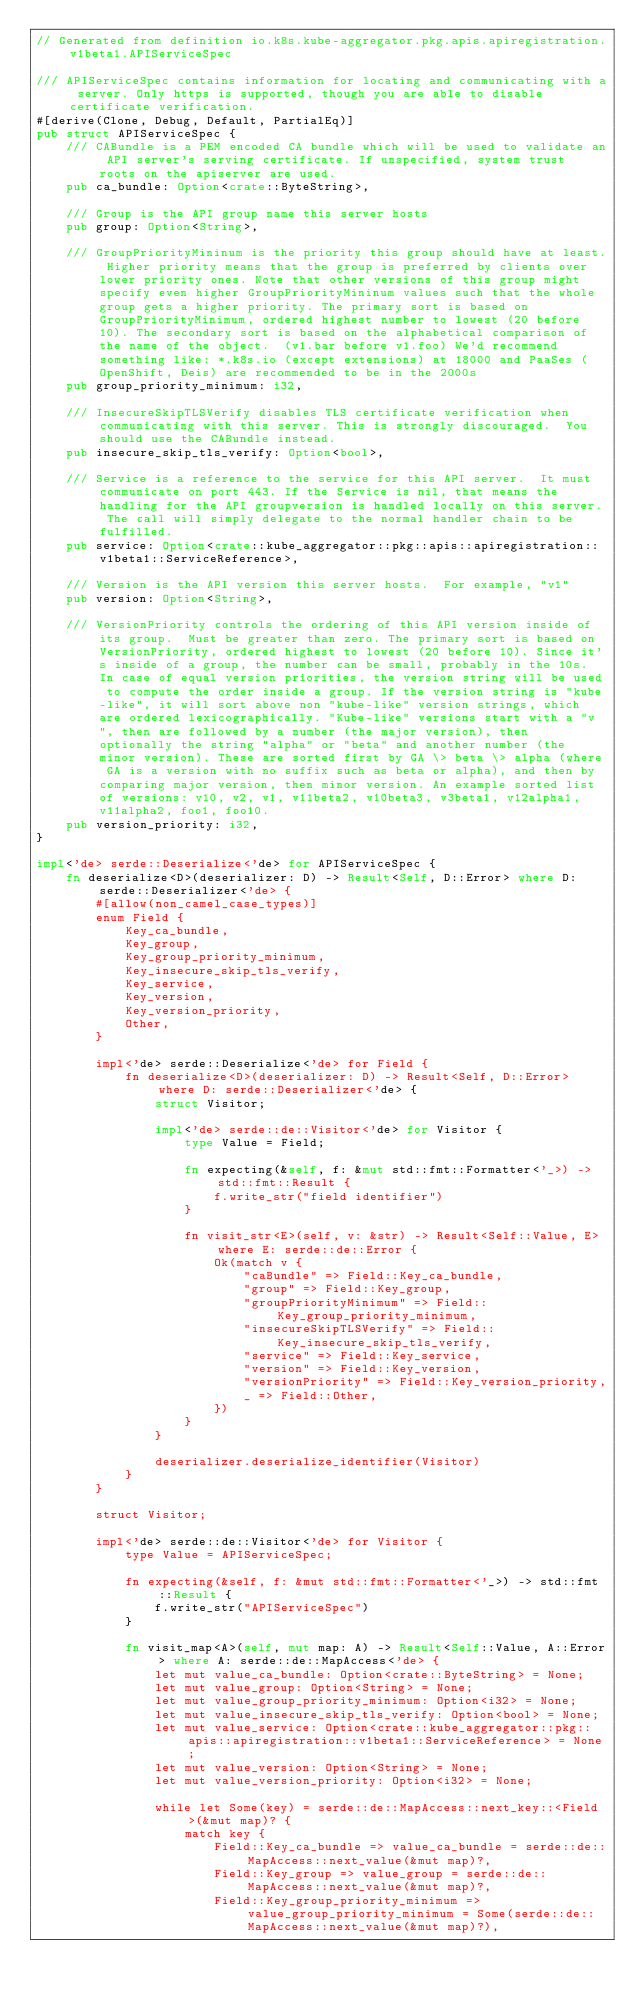Convert code to text. <code><loc_0><loc_0><loc_500><loc_500><_Rust_>// Generated from definition io.k8s.kube-aggregator.pkg.apis.apiregistration.v1beta1.APIServiceSpec

/// APIServiceSpec contains information for locating and communicating with a server. Only https is supported, though you are able to disable certificate verification.
#[derive(Clone, Debug, Default, PartialEq)]
pub struct APIServiceSpec {
    /// CABundle is a PEM encoded CA bundle which will be used to validate an API server's serving certificate. If unspecified, system trust roots on the apiserver are used.
    pub ca_bundle: Option<crate::ByteString>,

    /// Group is the API group name this server hosts
    pub group: Option<String>,

    /// GroupPriorityMininum is the priority this group should have at least. Higher priority means that the group is preferred by clients over lower priority ones. Note that other versions of this group might specify even higher GroupPriorityMininum values such that the whole group gets a higher priority. The primary sort is based on GroupPriorityMinimum, ordered highest number to lowest (20 before 10). The secondary sort is based on the alphabetical comparison of the name of the object.  (v1.bar before v1.foo) We'd recommend something like: *.k8s.io (except extensions) at 18000 and PaaSes (OpenShift, Deis) are recommended to be in the 2000s
    pub group_priority_minimum: i32,

    /// InsecureSkipTLSVerify disables TLS certificate verification when communicating with this server. This is strongly discouraged.  You should use the CABundle instead.
    pub insecure_skip_tls_verify: Option<bool>,

    /// Service is a reference to the service for this API server.  It must communicate on port 443. If the Service is nil, that means the handling for the API groupversion is handled locally on this server. The call will simply delegate to the normal handler chain to be fulfilled.
    pub service: Option<crate::kube_aggregator::pkg::apis::apiregistration::v1beta1::ServiceReference>,

    /// Version is the API version this server hosts.  For example, "v1"
    pub version: Option<String>,

    /// VersionPriority controls the ordering of this API version inside of its group.  Must be greater than zero. The primary sort is based on VersionPriority, ordered highest to lowest (20 before 10). Since it's inside of a group, the number can be small, probably in the 10s. In case of equal version priorities, the version string will be used to compute the order inside a group. If the version string is "kube-like", it will sort above non "kube-like" version strings, which are ordered lexicographically. "Kube-like" versions start with a "v", then are followed by a number (the major version), then optionally the string "alpha" or "beta" and another number (the minor version). These are sorted first by GA \> beta \> alpha (where GA is a version with no suffix such as beta or alpha), and then by comparing major version, then minor version. An example sorted list of versions: v10, v2, v1, v11beta2, v10beta3, v3beta1, v12alpha1, v11alpha2, foo1, foo10.
    pub version_priority: i32,
}

impl<'de> serde::Deserialize<'de> for APIServiceSpec {
    fn deserialize<D>(deserializer: D) -> Result<Self, D::Error> where D: serde::Deserializer<'de> {
        #[allow(non_camel_case_types)]
        enum Field {
            Key_ca_bundle,
            Key_group,
            Key_group_priority_minimum,
            Key_insecure_skip_tls_verify,
            Key_service,
            Key_version,
            Key_version_priority,
            Other,
        }

        impl<'de> serde::Deserialize<'de> for Field {
            fn deserialize<D>(deserializer: D) -> Result<Self, D::Error> where D: serde::Deserializer<'de> {
                struct Visitor;

                impl<'de> serde::de::Visitor<'de> for Visitor {
                    type Value = Field;

                    fn expecting(&self, f: &mut std::fmt::Formatter<'_>) -> std::fmt::Result {
                        f.write_str("field identifier")
                    }

                    fn visit_str<E>(self, v: &str) -> Result<Self::Value, E> where E: serde::de::Error {
                        Ok(match v {
                            "caBundle" => Field::Key_ca_bundle,
                            "group" => Field::Key_group,
                            "groupPriorityMinimum" => Field::Key_group_priority_minimum,
                            "insecureSkipTLSVerify" => Field::Key_insecure_skip_tls_verify,
                            "service" => Field::Key_service,
                            "version" => Field::Key_version,
                            "versionPriority" => Field::Key_version_priority,
                            _ => Field::Other,
                        })
                    }
                }

                deserializer.deserialize_identifier(Visitor)
            }
        }

        struct Visitor;

        impl<'de> serde::de::Visitor<'de> for Visitor {
            type Value = APIServiceSpec;

            fn expecting(&self, f: &mut std::fmt::Formatter<'_>) -> std::fmt::Result {
                f.write_str("APIServiceSpec")
            }

            fn visit_map<A>(self, mut map: A) -> Result<Self::Value, A::Error> where A: serde::de::MapAccess<'de> {
                let mut value_ca_bundle: Option<crate::ByteString> = None;
                let mut value_group: Option<String> = None;
                let mut value_group_priority_minimum: Option<i32> = None;
                let mut value_insecure_skip_tls_verify: Option<bool> = None;
                let mut value_service: Option<crate::kube_aggregator::pkg::apis::apiregistration::v1beta1::ServiceReference> = None;
                let mut value_version: Option<String> = None;
                let mut value_version_priority: Option<i32> = None;

                while let Some(key) = serde::de::MapAccess::next_key::<Field>(&mut map)? {
                    match key {
                        Field::Key_ca_bundle => value_ca_bundle = serde::de::MapAccess::next_value(&mut map)?,
                        Field::Key_group => value_group = serde::de::MapAccess::next_value(&mut map)?,
                        Field::Key_group_priority_minimum => value_group_priority_minimum = Some(serde::de::MapAccess::next_value(&mut map)?),</code> 